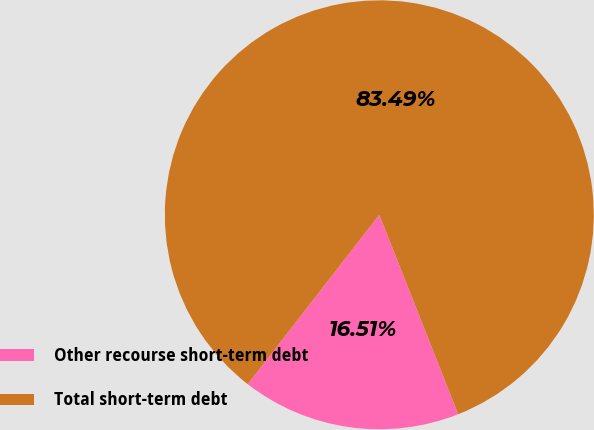Convert chart. <chart><loc_0><loc_0><loc_500><loc_500><pie_chart><fcel>Other recourse short-term debt<fcel>Total short-term debt<nl><fcel>16.51%<fcel>83.49%<nl></chart> 